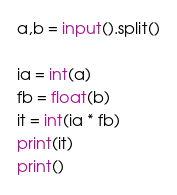<code> <loc_0><loc_0><loc_500><loc_500><_Python_>a,b = input().split()

ia = int(a)
fb = float(b)
it = int(ia * fb)
print(it)
print()</code> 